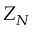Convert formula to latex. <formula><loc_0><loc_0><loc_500><loc_500>Z _ { N }</formula> 